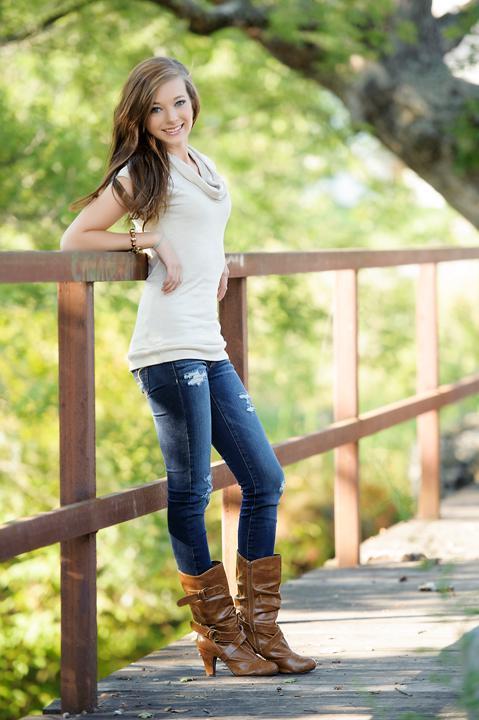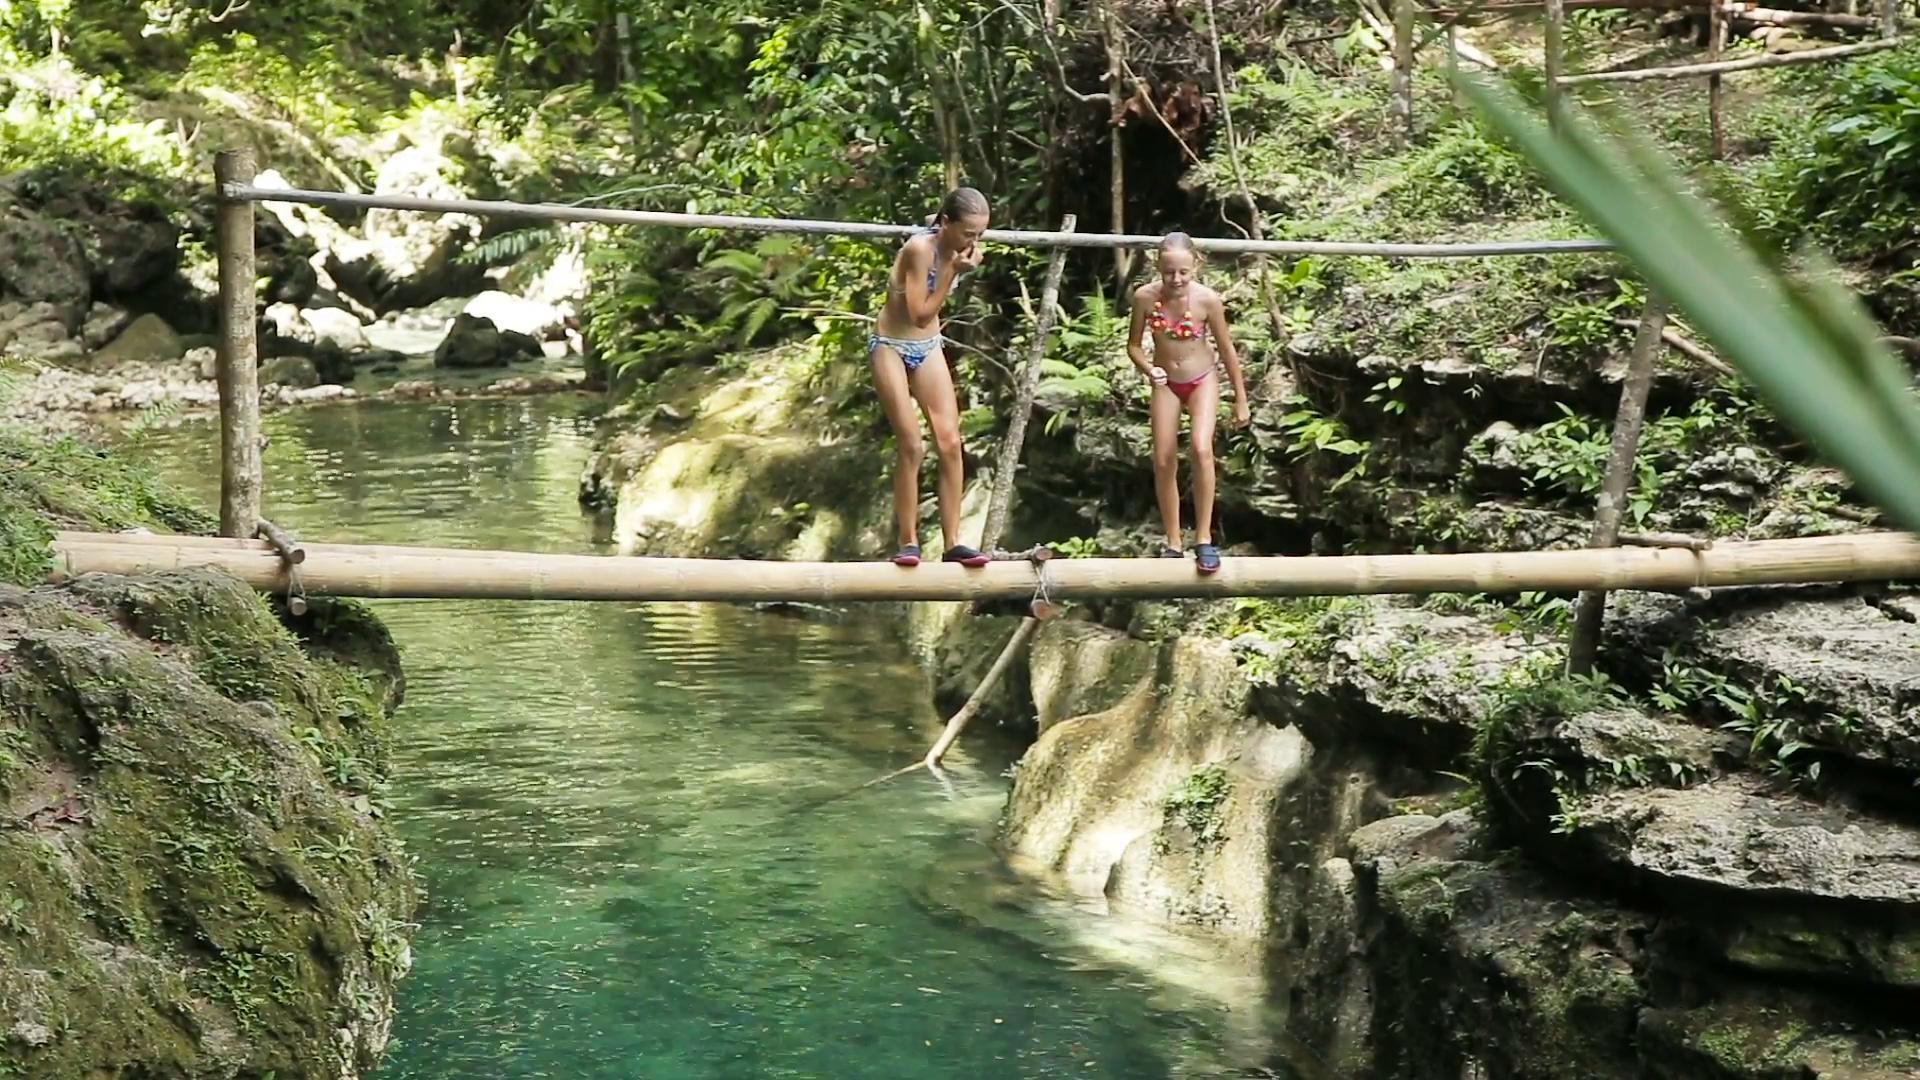The first image is the image on the left, the second image is the image on the right. Considering the images on both sides, is "One image shows exactly one girl standing and leaning with her arms on a rail, and smiling at the camera." valid? Answer yes or no. Yes. The first image is the image on the left, the second image is the image on the right. Analyze the images presented: Is the assertion "In one image is a pair of girls together and the other image is one single girl." valid? Answer yes or no. Yes. 